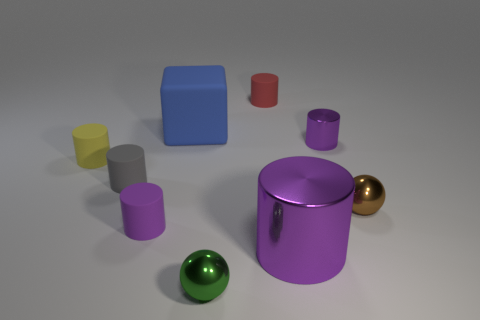Are there any other things that are the same shape as the blue rubber object?
Offer a very short reply. No. What is the size of the other shiny cylinder that is the same color as the small metal cylinder?
Make the answer very short. Large. Are there any other things that are the same color as the large block?
Keep it short and to the point. No. There is a shiny sphere to the left of the large cylinder; what is its size?
Offer a terse response. Small. What is the size of the purple matte cylinder that is to the left of the tiny ball right of the small red matte object that is left of the tiny metallic cylinder?
Make the answer very short. Small. The metal ball on the left side of the small purple cylinder that is on the right side of the large purple thing is what color?
Provide a short and direct response. Green. What material is the large purple object that is the same shape as the gray rubber thing?
Keep it short and to the point. Metal. Are there any objects behind the yellow object?
Your answer should be very brief. Yes. What number of things are there?
Your answer should be very brief. 9. What number of brown objects are behind the metal sphere that is on the right side of the green object?
Keep it short and to the point. 0. 